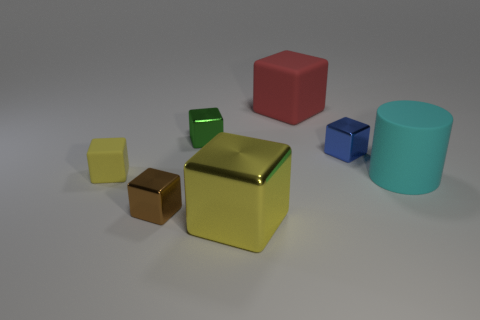Subtract all green shiny cubes. How many cubes are left? 5 Subtract all yellow cylinders. How many yellow cubes are left? 2 Add 3 cyan objects. How many objects exist? 10 Subtract all blue blocks. How many blocks are left? 5 Subtract all cylinders. How many objects are left? 6 Add 2 tiny yellow cubes. How many tiny yellow cubes are left? 3 Add 3 small yellow rubber blocks. How many small yellow rubber blocks exist? 4 Subtract 0 gray cylinders. How many objects are left? 7 Subtract all brown cylinders. Subtract all cyan balls. How many cylinders are left? 1 Subtract all purple rubber objects. Subtract all large cyan rubber cylinders. How many objects are left? 6 